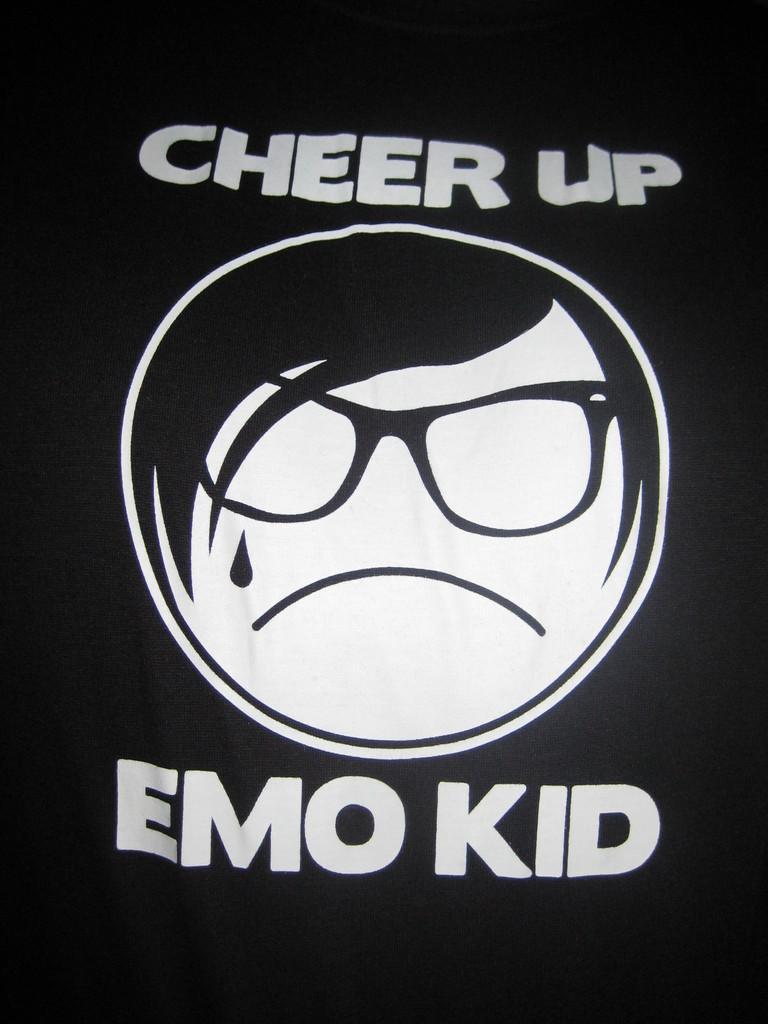How would you summarize this image in a sentence or two? In this picture I can see a print of words and a person face on an item. 